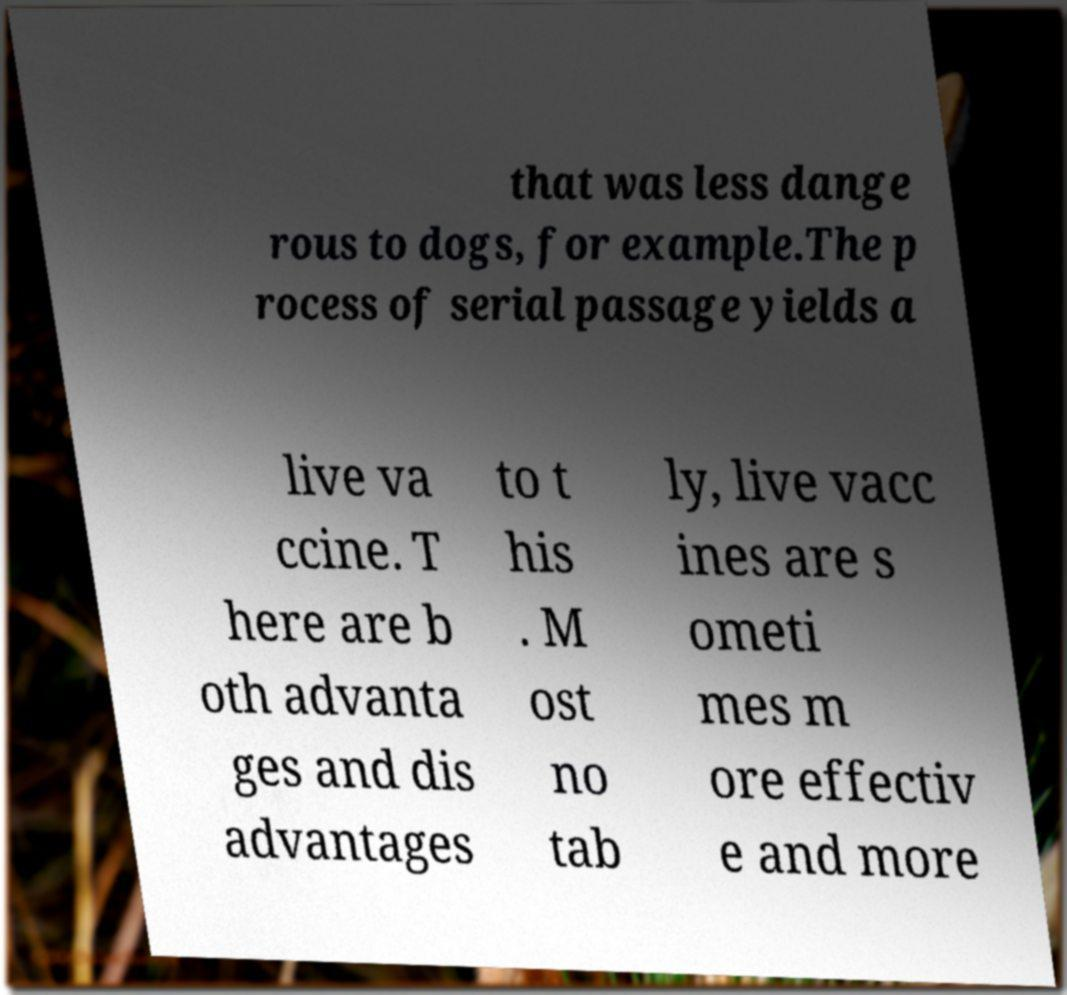Please read and relay the text visible in this image. What does it say? that was less dange rous to dogs, for example.The p rocess of serial passage yields a live va ccine. T here are b oth advanta ges and dis advantages to t his . M ost no tab ly, live vacc ines are s ometi mes m ore effectiv e and more 